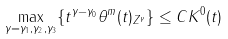Convert formula to latex. <formula><loc_0><loc_0><loc_500><loc_500>\max _ { \gamma = \gamma _ { 1 } , \gamma _ { 2 } , \gamma _ { 3 } } \{ t ^ { \gamma - \gamma _ { 0 } } \| \theta ^ { m } ( t ) \| _ { Z ^ { \gamma } } \} \leq C K ^ { 0 } ( t )</formula> 